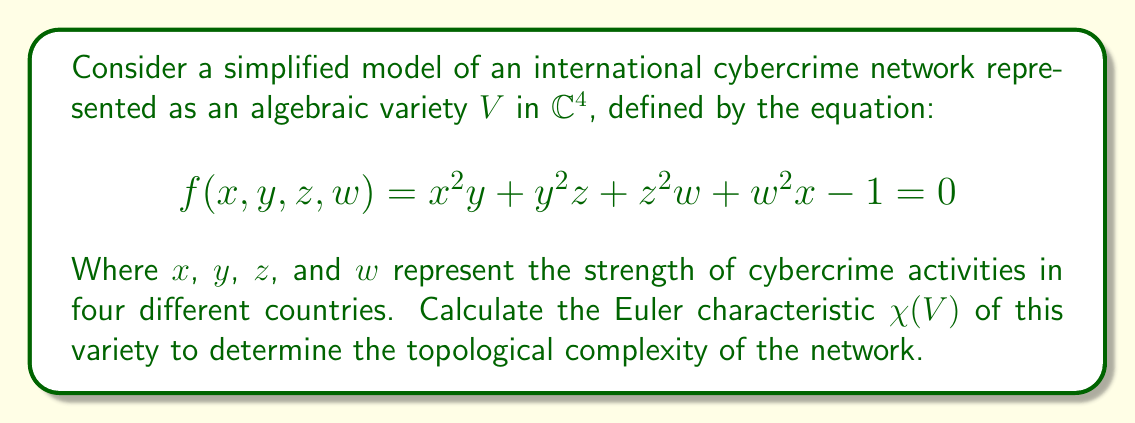What is the answer to this math problem? To calculate the Euler characteristic of the algebraic variety $V$, we'll follow these steps:

1) First, we need to determine the degree of the polynomial $f(x,y,z,w)$. The degree is 3.

2) For a smooth hypersurface $V$ of degree $d$ in $\mathbb{CP}^n$, the Euler characteristic is given by the formula:

   $$\chi(V) = \frac{1}{d}((d-1)^{n+1} + (-1)^n(n+1))$$

3) In our case, $d=3$ and $n=3$ (as we're in $\mathbb{CP}^3$, the projective closure of $\mathbb{C}^4$).

4) Substituting these values into the formula:

   $$\chi(V) = \frac{1}{3}((3-1)^{3+1} + (-1)^3(3+1))$$

5) Simplify:
   
   $$\chi(V) = \frac{1}{3}(2^4 - 4) = \frac{1}{3}(16 - 4) = \frac{12}{3} = 4$$

Therefore, the Euler characteristic of the cybercrime network variety is 4.

This result indicates that the topological complexity of the network is relatively low, suggesting that despite its international nature, the cybercrime network has a simple underlying structure. This could imply that targeting a few key nodes might significantly disrupt the entire network.
Answer: $\chi(V) = 4$ 